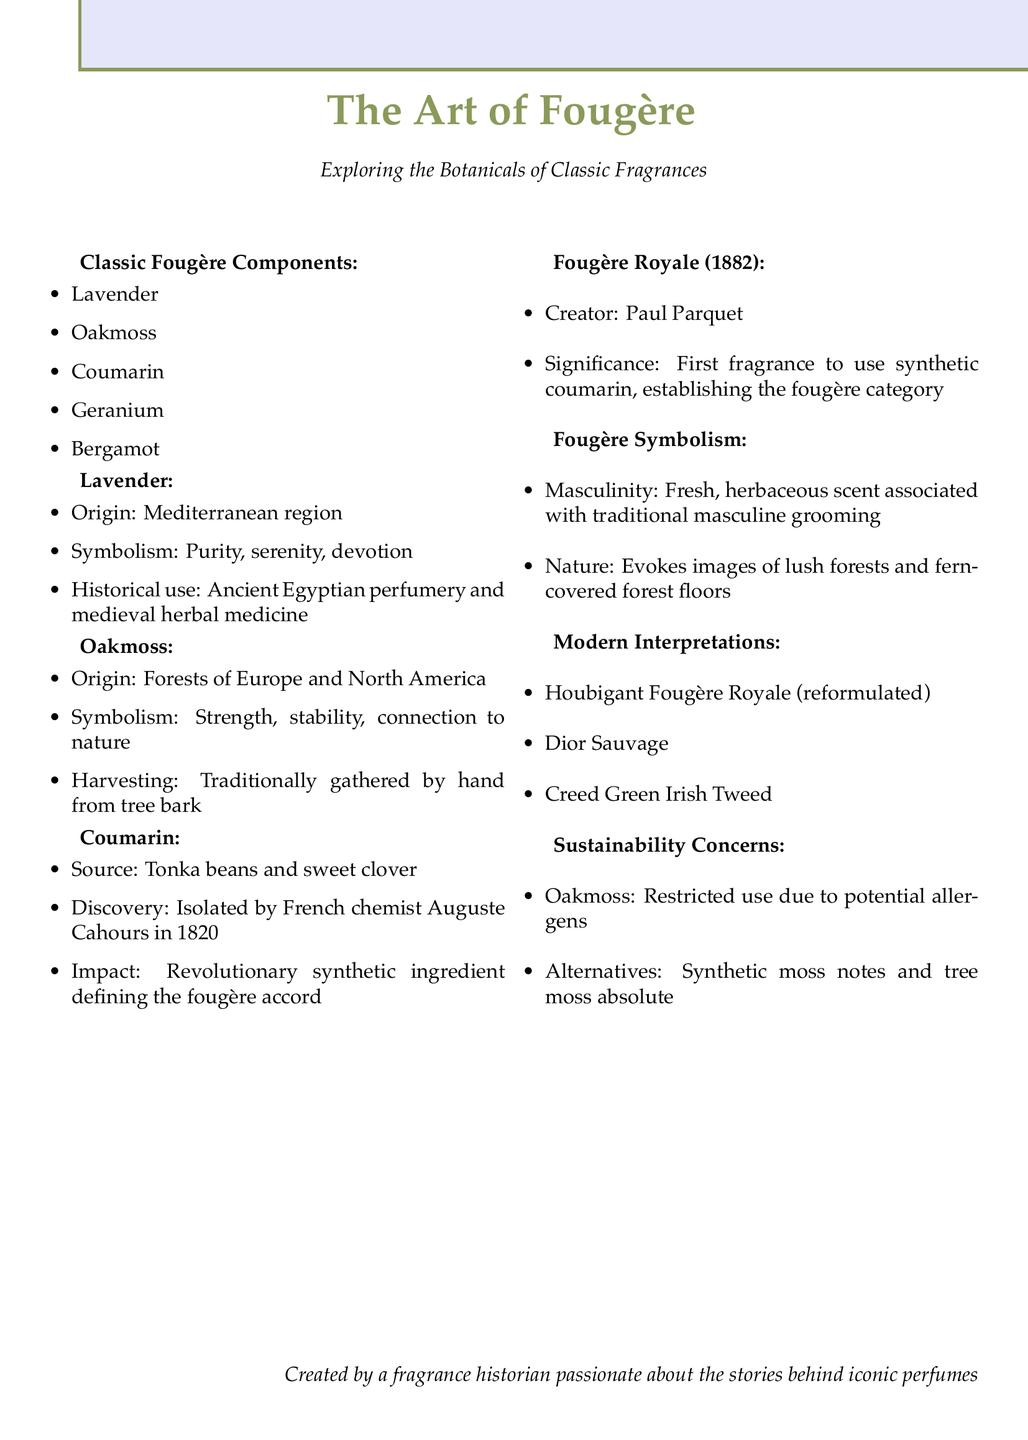What are the classic fougère components? The classic fougère components are listed as Lavender, Oakmoss, Coumarin, Geranium, and Bergamot.
Answer: Lavender, Oakmoss, Coumarin, Geranium, Bergamot Who created Fougère Royale? The document specifies that Fougère Royale was created by Paul Parquet.
Answer: Paul Parquet What year was Fougère Royale established? The document states that Fougère Royale was established in 1882.
Answer: 1882 What is the origin of Lavender? The document indicates that Lavender originates from the Mediterranean region.
Answer: Mediterranean region What is the symbolism of Oakmoss? According to the document, the symbolism of Oakmoss is strength, stability, and connection to nature.
Answer: Strength, stability, and connection to nature Why is coumarin significant in fougère fragrances? Coumarin is described as a revolutionary synthetic ingredient that defined the fougère accord, making it significant.
Answer: Revolutionary synthetic ingredient that defined the fougère accord What do modern interpretations of fougère fragrances include? Modern interpretations listed include Houbigant Fougère Royale, Dior Sauvage, and Creed Green Irish Tweed.
Answer: Houbigant Fougère Royale, Dior Sauvage, Creed Green Irish Tweed What is the harvesting method for Oakmoss? The document mentions that Oakmoss is traditionally gathered by hand from tree bark.
Answer: Hand from tree bark What does fougère symbolism evoke in nature? Fougère symbolism evokes images of lush forests and fern-covered forest floors in nature.
Answer: Lush forests and fern-covered forest floors 